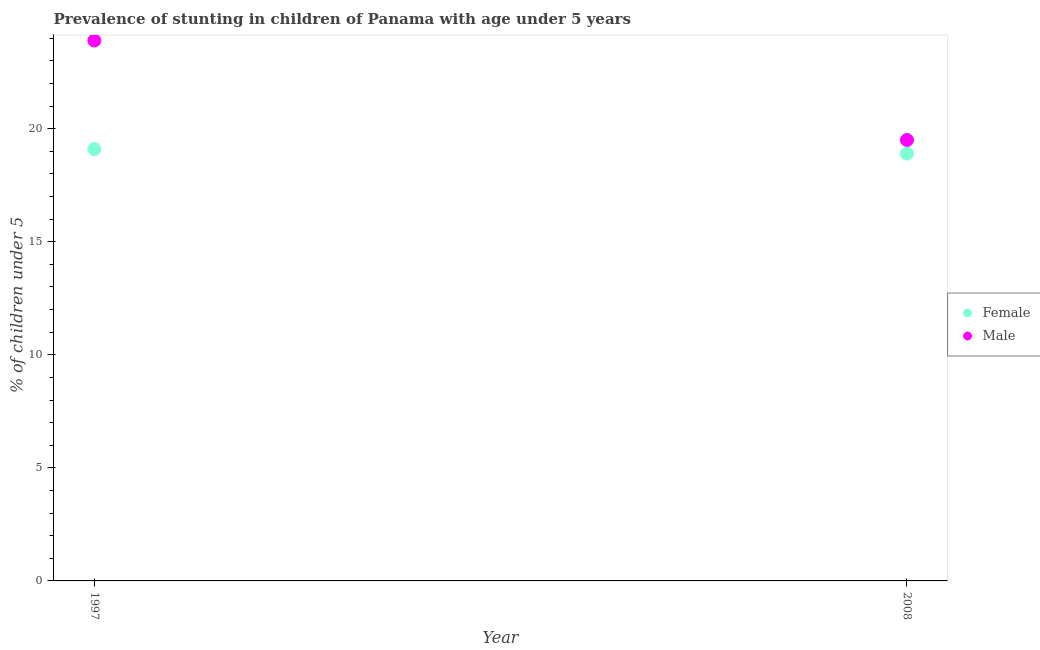Is the number of dotlines equal to the number of legend labels?
Make the answer very short. Yes. What is the percentage of stunted male children in 1997?
Provide a short and direct response. 23.9. Across all years, what is the maximum percentage of stunted male children?
Ensure brevity in your answer.  23.9. Across all years, what is the minimum percentage of stunted female children?
Provide a succinct answer. 18.9. In which year was the percentage of stunted female children maximum?
Give a very brief answer. 1997. In which year was the percentage of stunted female children minimum?
Provide a succinct answer. 2008. What is the difference between the percentage of stunted female children in 1997 and that in 2008?
Your answer should be compact. 0.2. What is the difference between the percentage of stunted female children in 1997 and the percentage of stunted male children in 2008?
Your response must be concise. -0.4. What is the average percentage of stunted female children per year?
Your response must be concise. 19. In the year 1997, what is the difference between the percentage of stunted male children and percentage of stunted female children?
Your answer should be very brief. 4.8. What is the ratio of the percentage of stunted male children in 1997 to that in 2008?
Your response must be concise. 1.23. Is the percentage of stunted female children in 1997 less than that in 2008?
Provide a short and direct response. No. In how many years, is the percentage of stunted female children greater than the average percentage of stunted female children taken over all years?
Ensure brevity in your answer.  1. Does the percentage of stunted male children monotonically increase over the years?
Keep it short and to the point. No. Is the percentage of stunted female children strictly less than the percentage of stunted male children over the years?
Offer a terse response. Yes. What is the difference between two consecutive major ticks on the Y-axis?
Ensure brevity in your answer.  5. Are the values on the major ticks of Y-axis written in scientific E-notation?
Ensure brevity in your answer.  No. Where does the legend appear in the graph?
Provide a succinct answer. Center right. How are the legend labels stacked?
Your response must be concise. Vertical. What is the title of the graph?
Your answer should be compact. Prevalence of stunting in children of Panama with age under 5 years. What is the label or title of the X-axis?
Offer a terse response. Year. What is the label or title of the Y-axis?
Offer a terse response.  % of children under 5. What is the  % of children under 5 of Female in 1997?
Provide a succinct answer. 19.1. What is the  % of children under 5 of Male in 1997?
Give a very brief answer. 23.9. What is the  % of children under 5 in Female in 2008?
Provide a succinct answer. 18.9. Across all years, what is the maximum  % of children under 5 of Female?
Give a very brief answer. 19.1. Across all years, what is the maximum  % of children under 5 of Male?
Ensure brevity in your answer.  23.9. Across all years, what is the minimum  % of children under 5 of Female?
Ensure brevity in your answer.  18.9. What is the total  % of children under 5 in Male in the graph?
Your answer should be very brief. 43.4. What is the average  % of children under 5 of Male per year?
Give a very brief answer. 21.7. In the year 1997, what is the difference between the  % of children under 5 in Female and  % of children under 5 in Male?
Provide a short and direct response. -4.8. In the year 2008, what is the difference between the  % of children under 5 of Female and  % of children under 5 of Male?
Provide a succinct answer. -0.6. What is the ratio of the  % of children under 5 in Female in 1997 to that in 2008?
Ensure brevity in your answer.  1.01. What is the ratio of the  % of children under 5 of Male in 1997 to that in 2008?
Keep it short and to the point. 1.23. What is the difference between the highest and the second highest  % of children under 5 of Female?
Your response must be concise. 0.2. What is the difference between the highest and the lowest  % of children under 5 of Female?
Offer a very short reply. 0.2. What is the difference between the highest and the lowest  % of children under 5 of Male?
Offer a terse response. 4.4. 